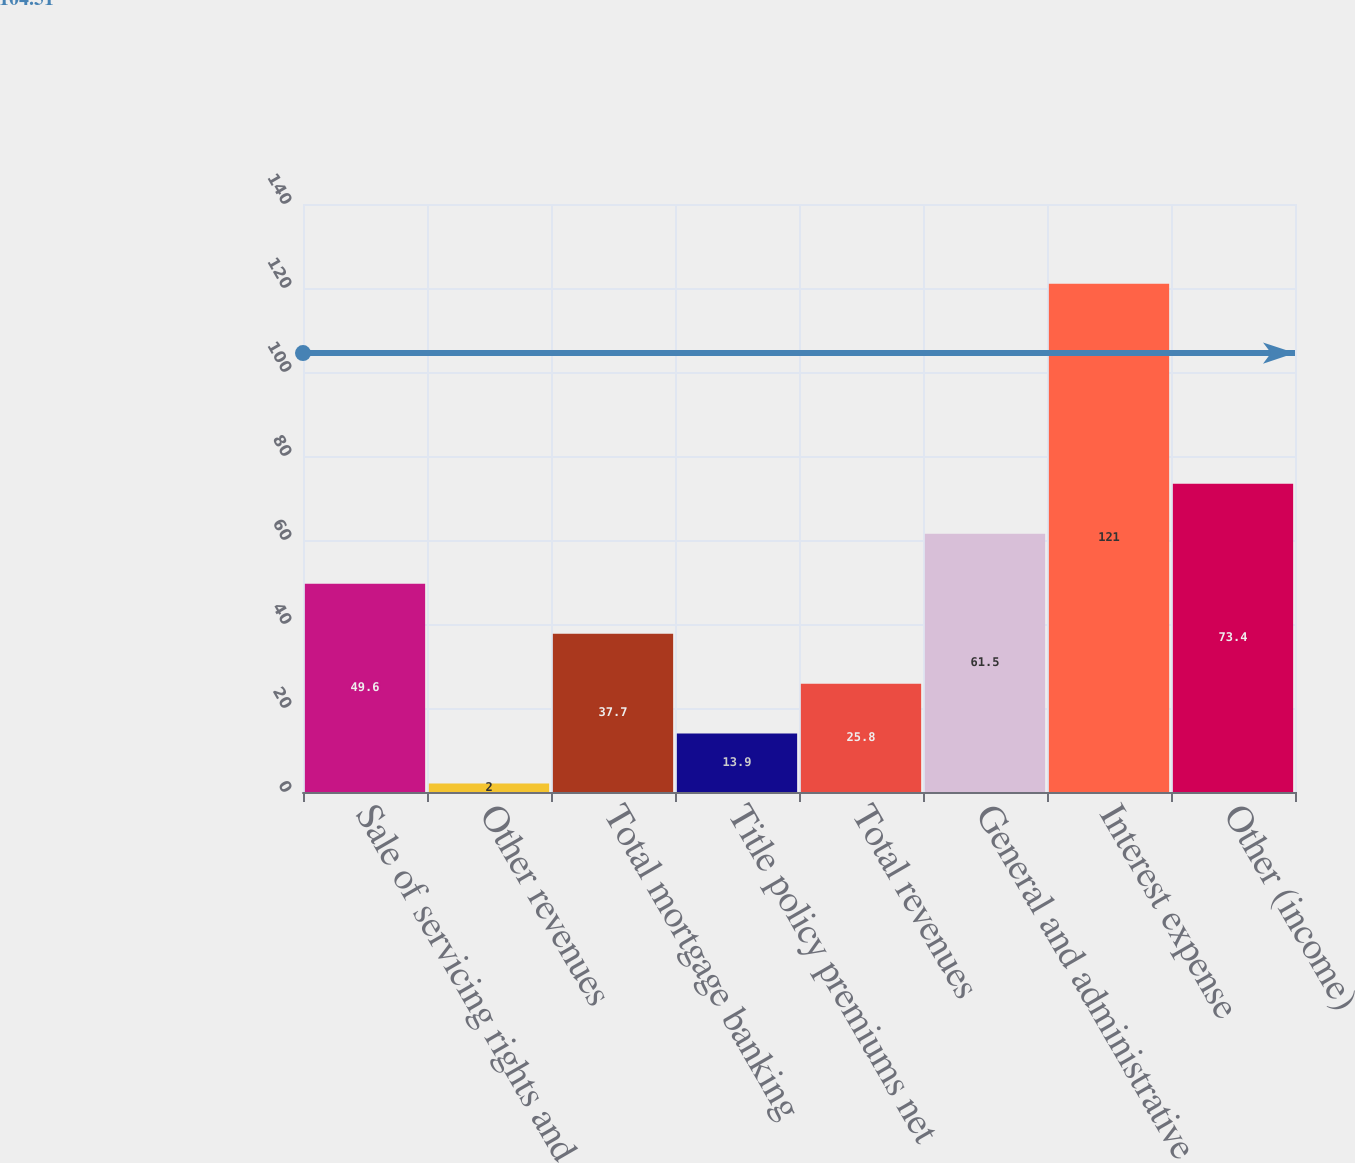Convert chart. <chart><loc_0><loc_0><loc_500><loc_500><bar_chart><fcel>Sale of servicing rights and<fcel>Other revenues<fcel>Total mortgage banking<fcel>Title policy premiums net<fcel>Total revenues<fcel>General and administrative<fcel>Interest expense<fcel>Other (income)<nl><fcel>49.6<fcel>2<fcel>37.7<fcel>13.9<fcel>25.8<fcel>61.5<fcel>121<fcel>73.4<nl></chart> 